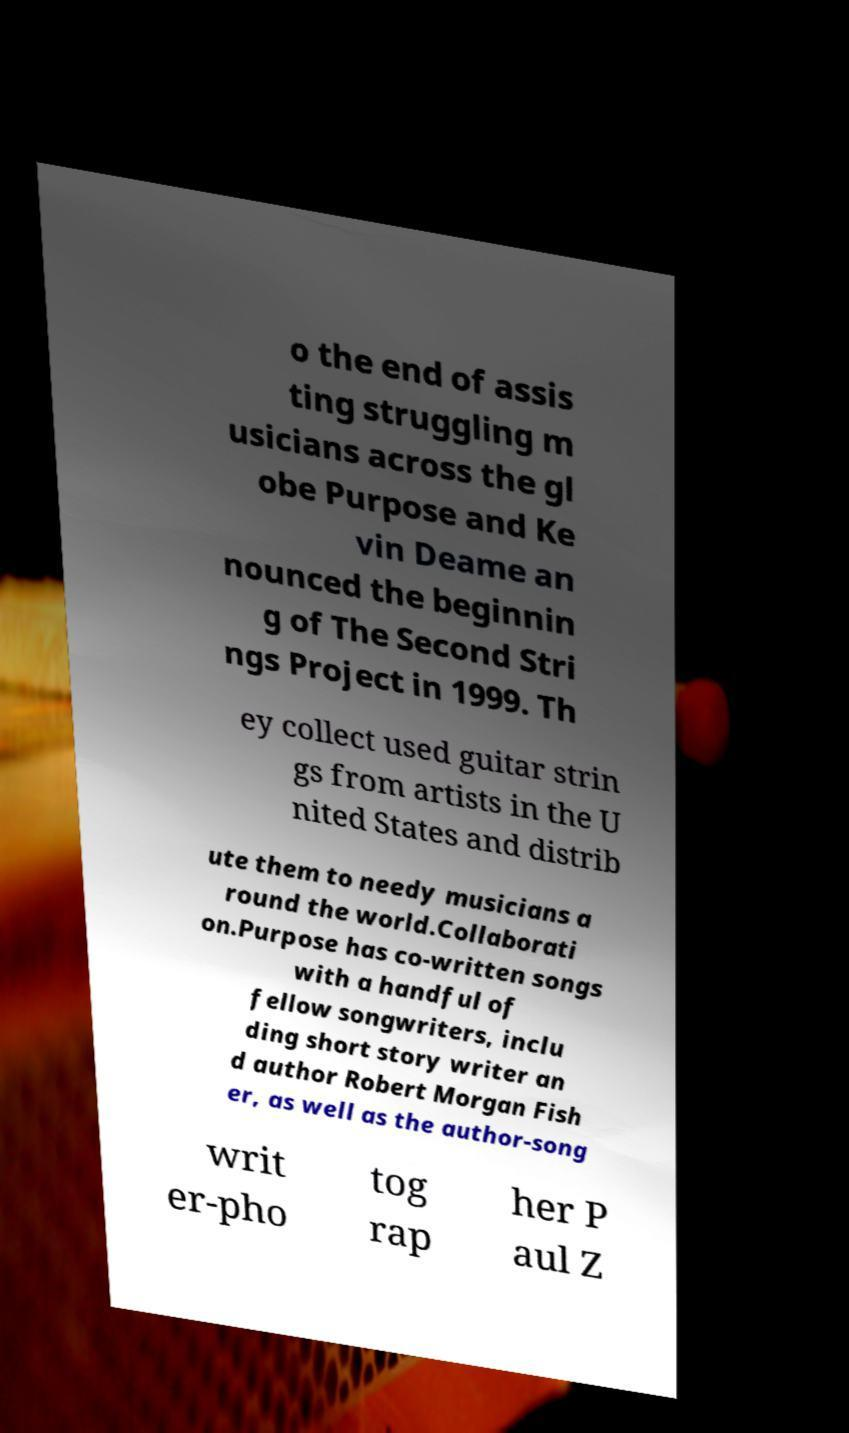What messages or text are displayed in this image? I need them in a readable, typed format. o the end of assis ting struggling m usicians across the gl obe Purpose and Ke vin Deame an nounced the beginnin g of The Second Stri ngs Project in 1999. Th ey collect used guitar strin gs from artists in the U nited States and distrib ute them to needy musicians a round the world.Collaborati on.Purpose has co-written songs with a handful of fellow songwriters, inclu ding short story writer an d author Robert Morgan Fish er, as well as the author-song writ er-pho tog rap her P aul Z 